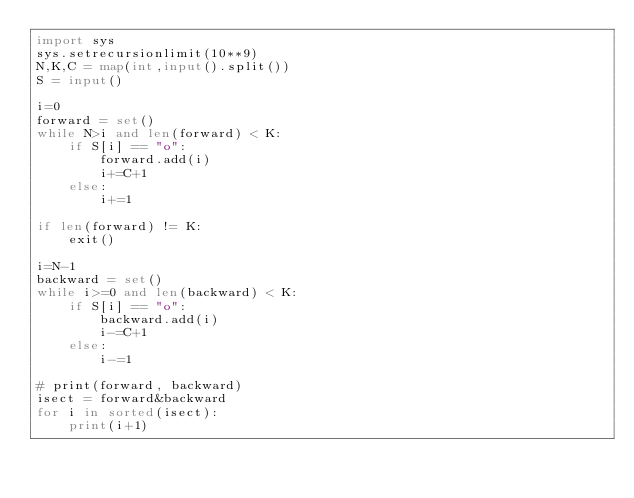Convert code to text. <code><loc_0><loc_0><loc_500><loc_500><_Python_>import sys
sys.setrecursionlimit(10**9)
N,K,C = map(int,input().split())
S = input()

i=0
forward = set()
while N>i and len(forward) < K:
    if S[i] == "o":
        forward.add(i)
        i+=C+1
    else:
        i+=1

if len(forward) != K:
    exit()

i=N-1
backward = set()
while i>=0 and len(backward) < K:
    if S[i] == "o":
        backward.add(i)
        i-=C+1
    else:
        i-=1
    
# print(forward, backward)
isect = forward&backward
for i in sorted(isect):
    print(i+1)
</code> 